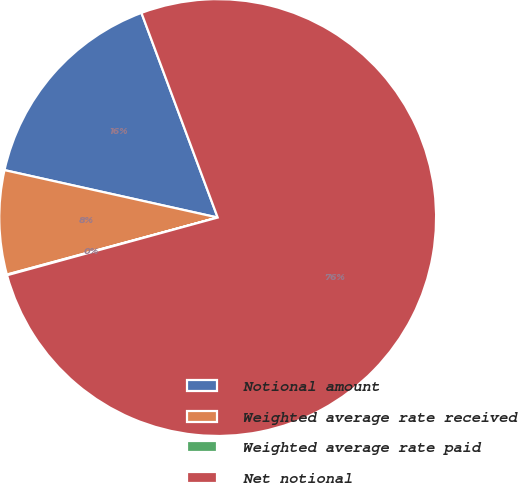Convert chart. <chart><loc_0><loc_0><loc_500><loc_500><pie_chart><fcel>Notional amount<fcel>Weighted average rate received<fcel>Weighted average rate paid<fcel>Net notional<nl><fcel>15.84%<fcel>7.69%<fcel>0.05%<fcel>76.42%<nl></chart> 